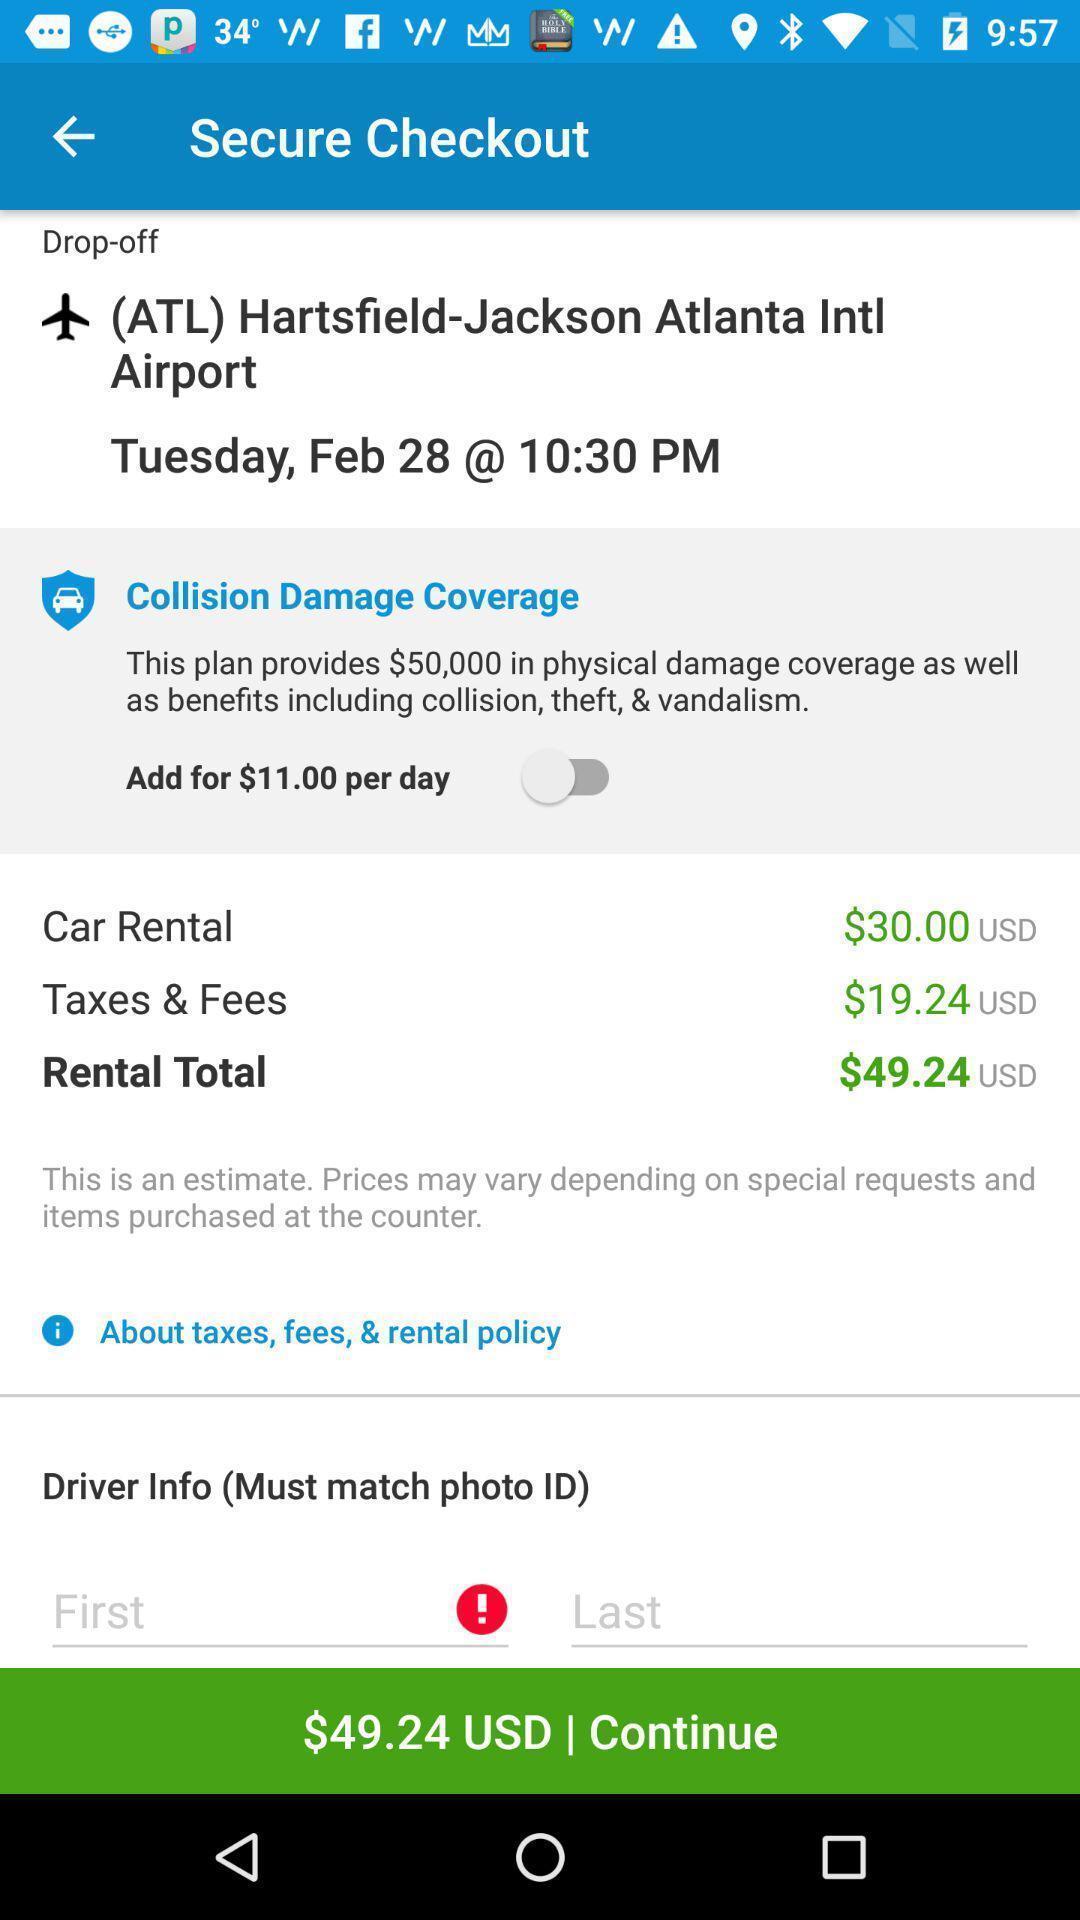Summarize the main components in this picture. Screen displaying payment continuation page in a travel app. 